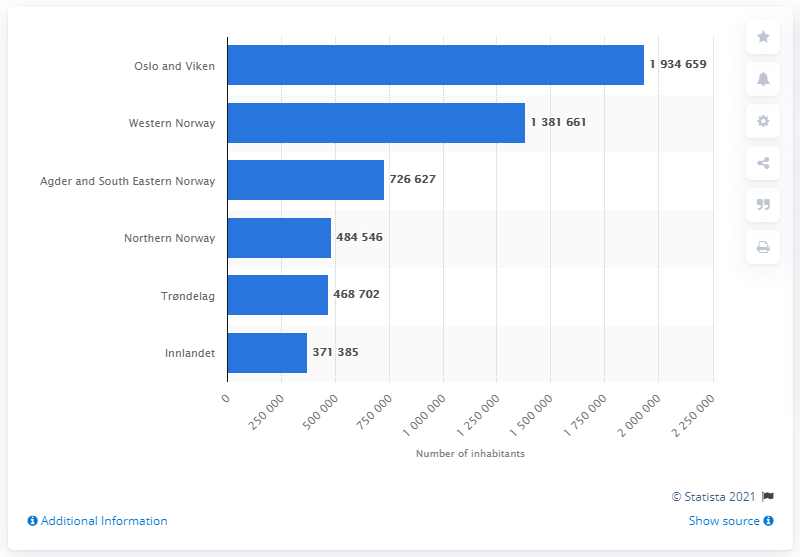Highlight a few significant elements in this photo. As of 2020, the Innlandet region had a population of 371,385 people. The most populous region in Norway is Oslo and Viken. 